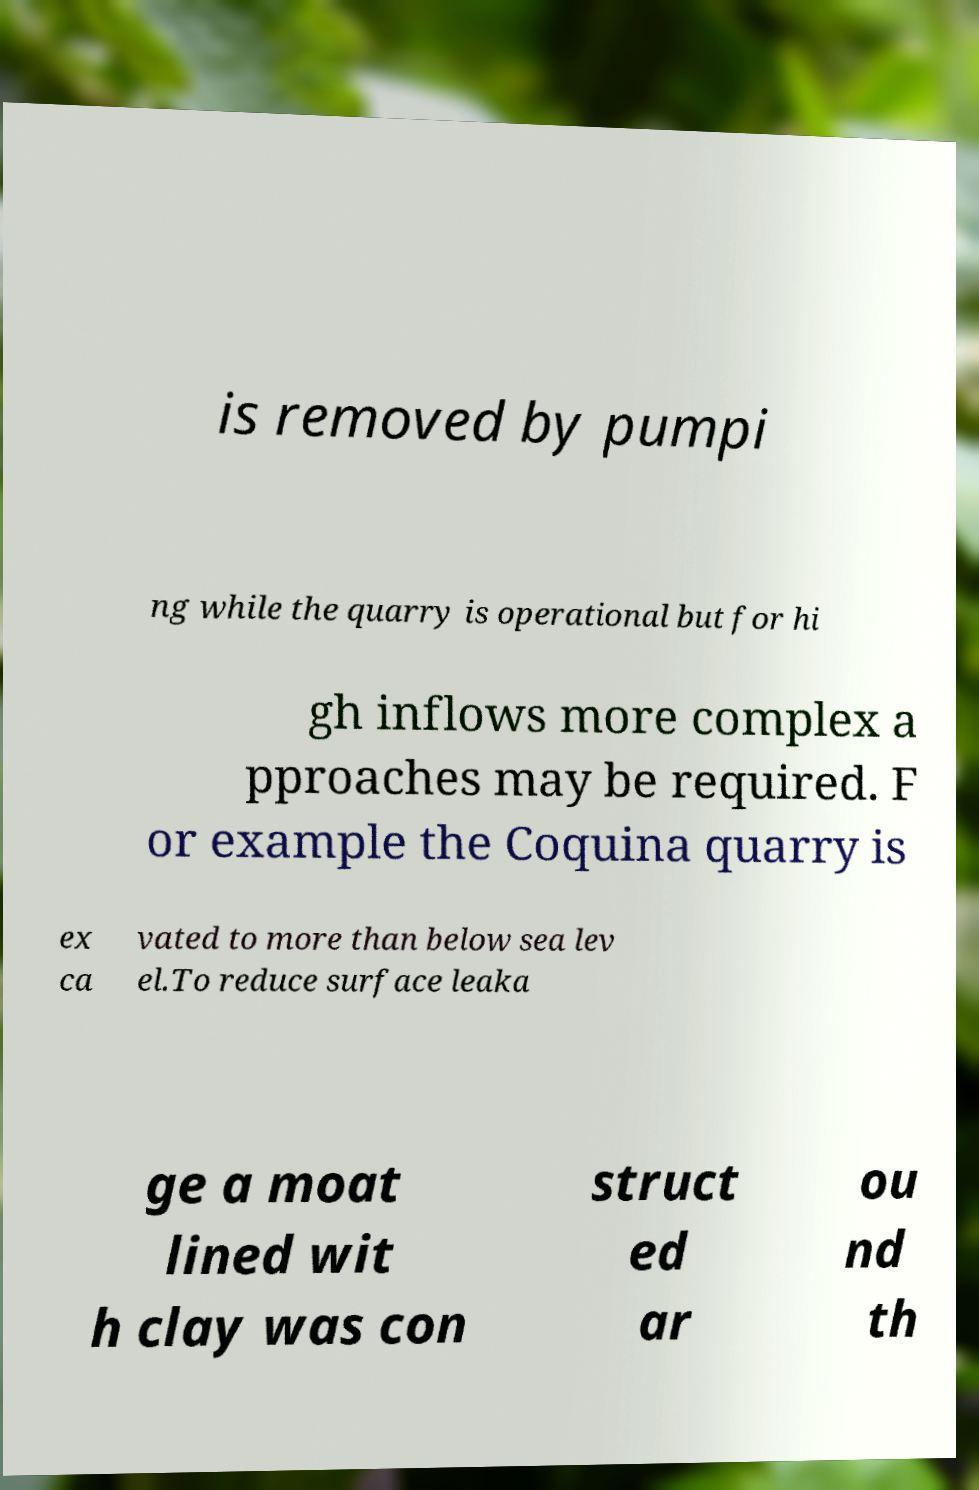What messages or text are displayed in this image? I need them in a readable, typed format. is removed by pumpi ng while the quarry is operational but for hi gh inflows more complex a pproaches may be required. F or example the Coquina quarry is ex ca vated to more than below sea lev el.To reduce surface leaka ge a moat lined wit h clay was con struct ed ar ou nd th 